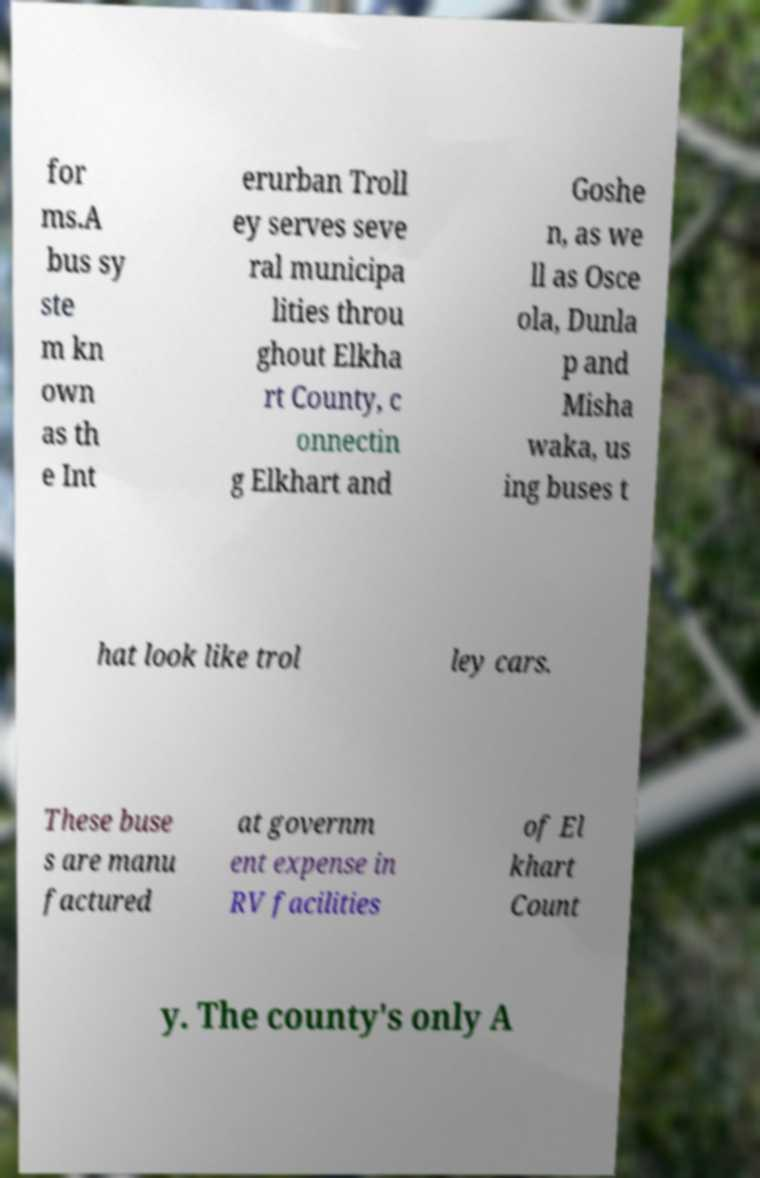Please read and relay the text visible in this image. What does it say? for ms.A bus sy ste m kn own as th e Int erurban Troll ey serves seve ral municipa lities throu ghout Elkha rt County, c onnectin g Elkhart and Goshe n, as we ll as Osce ola, Dunla p and Misha waka, us ing buses t hat look like trol ley cars. These buse s are manu factured at governm ent expense in RV facilities of El khart Count y. The county's only A 